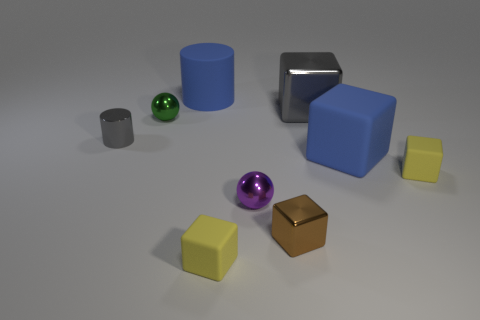Subtract all blue blocks. How many blocks are left? 4 Subtract all brown blocks. How many blocks are left? 4 Subtract 1 blocks. How many blocks are left? 4 Subtract all cyan cubes. Subtract all blue cylinders. How many cubes are left? 5 Add 1 large things. How many objects exist? 10 Subtract all cylinders. How many objects are left? 7 Add 5 large shiny blocks. How many large shiny blocks exist? 6 Subtract 0 red cylinders. How many objects are left? 9 Subtract all small green shiny objects. Subtract all small green shiny spheres. How many objects are left? 7 Add 7 small metal blocks. How many small metal blocks are left? 8 